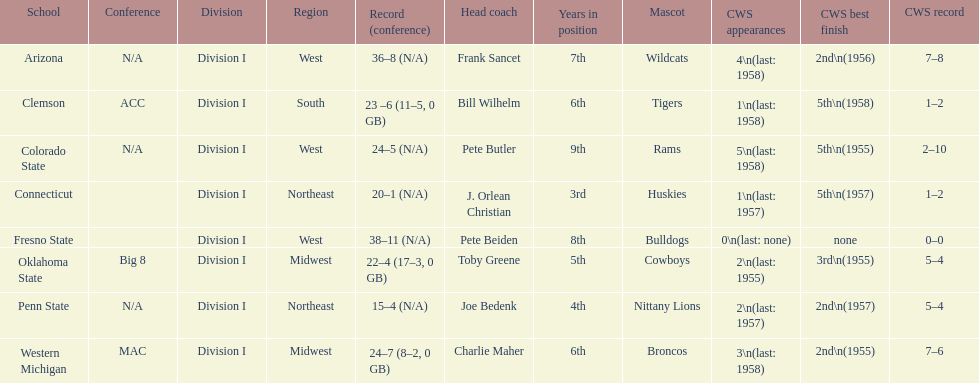How many teams reached their highest cws ranking in 1955? 3. 